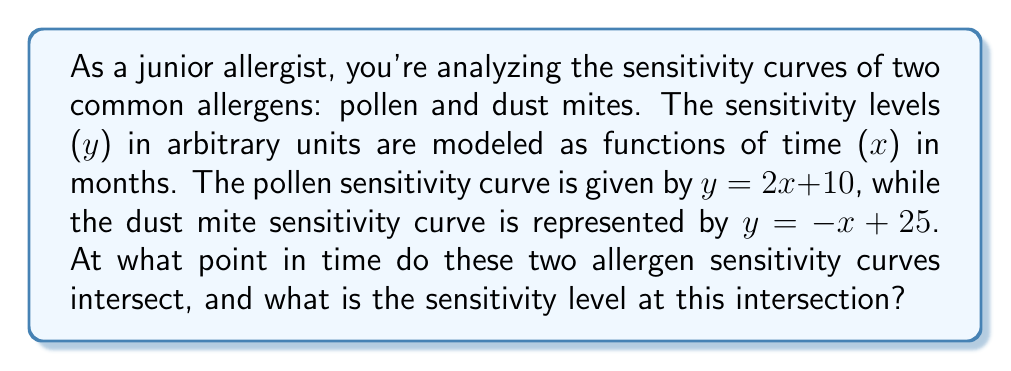Can you solve this math problem? To find the intersection point of these two allergen sensitivity curves, we need to solve the system of linear equations:

1) Pollen sensitivity: $y = 2x + 10$
2) Dust mite sensitivity: $y = -x + 25$

At the intersection point, the y-values (sensitivity levels) will be equal for both equations. So we can set them equal to each other:

$2x + 10 = -x + 25$

Now, let's solve this equation:

1) Add $x$ to both sides:
   $3x + 10 = 25$

2) Subtract 10 from both sides:
   $3x = 15$

3) Divide both sides by 3:
   $x = 5$

This means the intersection occurs at 5 months.

To find the sensitivity level at this point, we can plug $x = 5$ into either of the original equations. Let's use the pollen equation:

$y = 2(5) + 10 = 10 + 10 = 20$

Therefore, the intersection point is at (5, 20), meaning at 5 months with a sensitivity level of 20 arbitrary units.
Answer: (5, 20) 